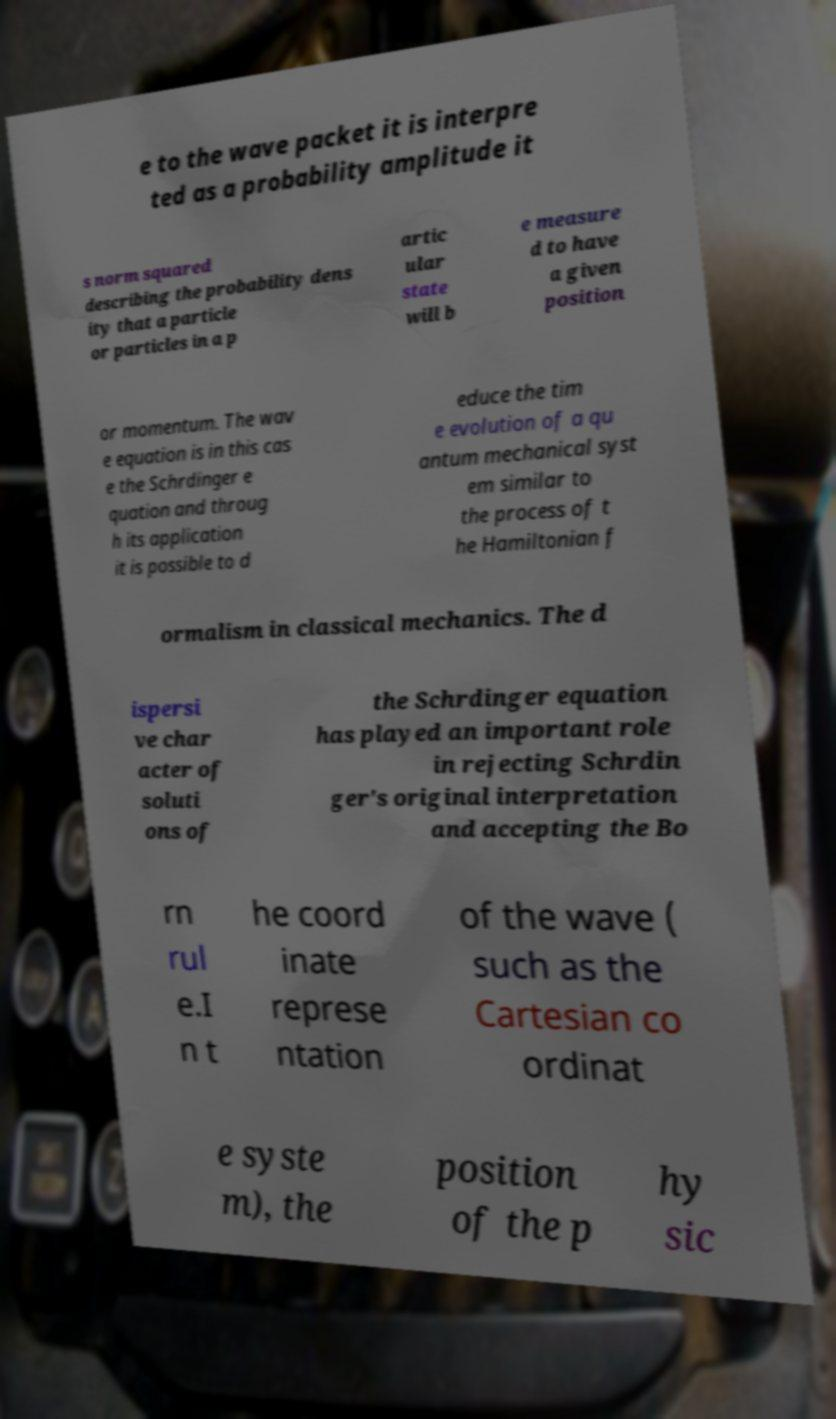Can you accurately transcribe the text from the provided image for me? e to the wave packet it is interpre ted as a probability amplitude it s norm squared describing the probability dens ity that a particle or particles in a p artic ular state will b e measure d to have a given position or momentum. The wav e equation is in this cas e the Schrdinger e quation and throug h its application it is possible to d educe the tim e evolution of a qu antum mechanical syst em similar to the process of t he Hamiltonian f ormalism in classical mechanics. The d ispersi ve char acter of soluti ons of the Schrdinger equation has played an important role in rejecting Schrdin ger's original interpretation and accepting the Bo rn rul e.I n t he coord inate represe ntation of the wave ( such as the Cartesian co ordinat e syste m), the position of the p hy sic 